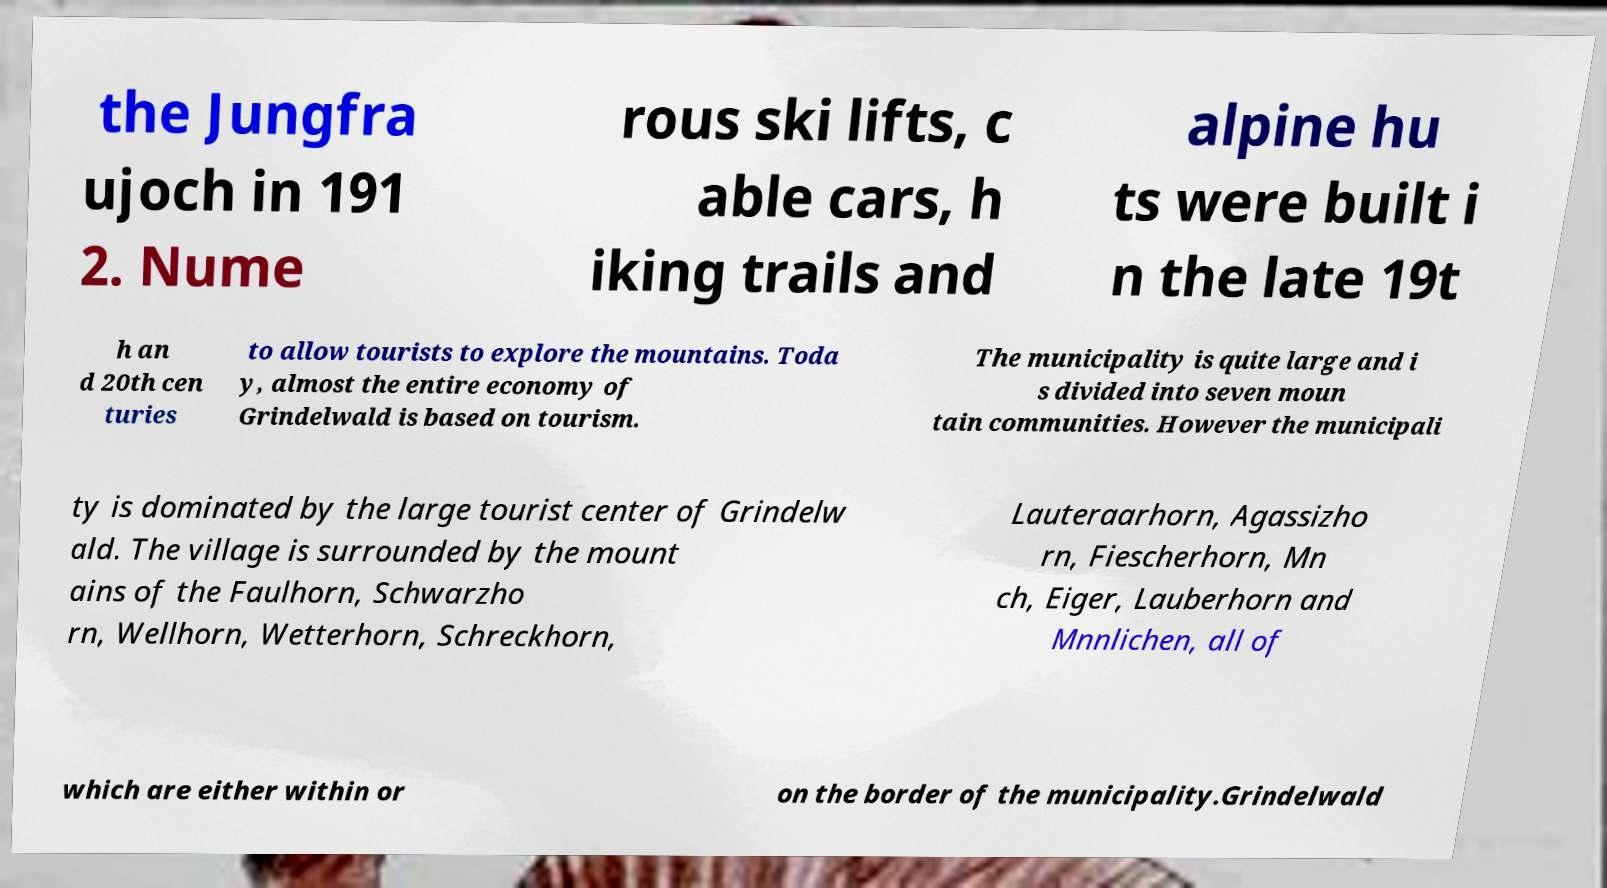There's text embedded in this image that I need extracted. Can you transcribe it verbatim? the Jungfra ujoch in 191 2. Nume rous ski lifts, c able cars, h iking trails and alpine hu ts were built i n the late 19t h an d 20th cen turies to allow tourists to explore the mountains. Toda y, almost the entire economy of Grindelwald is based on tourism. The municipality is quite large and i s divided into seven moun tain communities. However the municipali ty is dominated by the large tourist center of Grindelw ald. The village is surrounded by the mount ains of the Faulhorn, Schwarzho rn, Wellhorn, Wetterhorn, Schreckhorn, Lauteraarhorn, Agassizho rn, Fiescherhorn, Mn ch, Eiger, Lauberhorn and Mnnlichen, all of which are either within or on the border of the municipality.Grindelwald 